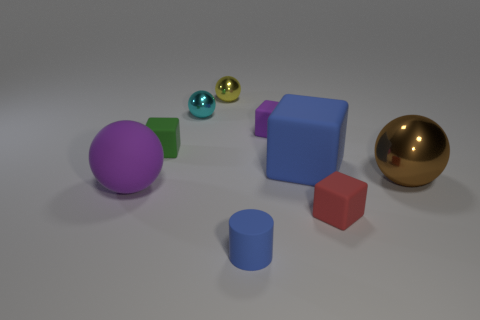There is a block that is the same color as the matte sphere; what is its material?
Your answer should be compact. Rubber. There is a small green thing that is the same shape as the small red object; what is it made of?
Make the answer very short. Rubber. Are there any red matte things left of the small metal sphere behind the cyan metallic object?
Your response must be concise. No. Does the big blue thing have the same shape as the cyan thing?
Ensure brevity in your answer.  No. There is a small blue object that is the same material as the tiny purple thing; what is its shape?
Give a very brief answer. Cylinder. Does the block left of the tiny purple rubber cube have the same size as the blue rubber cylinder on the left side of the large brown thing?
Offer a terse response. Yes. Is the number of rubber cylinders that are behind the tiny blue rubber thing greater than the number of red blocks that are to the right of the purple rubber ball?
Ensure brevity in your answer.  No. How many other objects are there of the same color as the big shiny sphere?
Give a very brief answer. 0. There is a small cylinder; is its color the same as the shiny object to the right of the red rubber block?
Make the answer very short. No. How many matte objects are behind the sphere that is right of the small blue object?
Offer a very short reply. 3. 